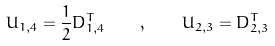Convert formula to latex. <formula><loc_0><loc_0><loc_500><loc_500>U _ { 1 , 4 } = \frac { 1 } { 2 } D _ { 1 , 4 } ^ { T } \quad , \quad U _ { 2 , 3 } = D _ { 2 , 3 } ^ { T }</formula> 